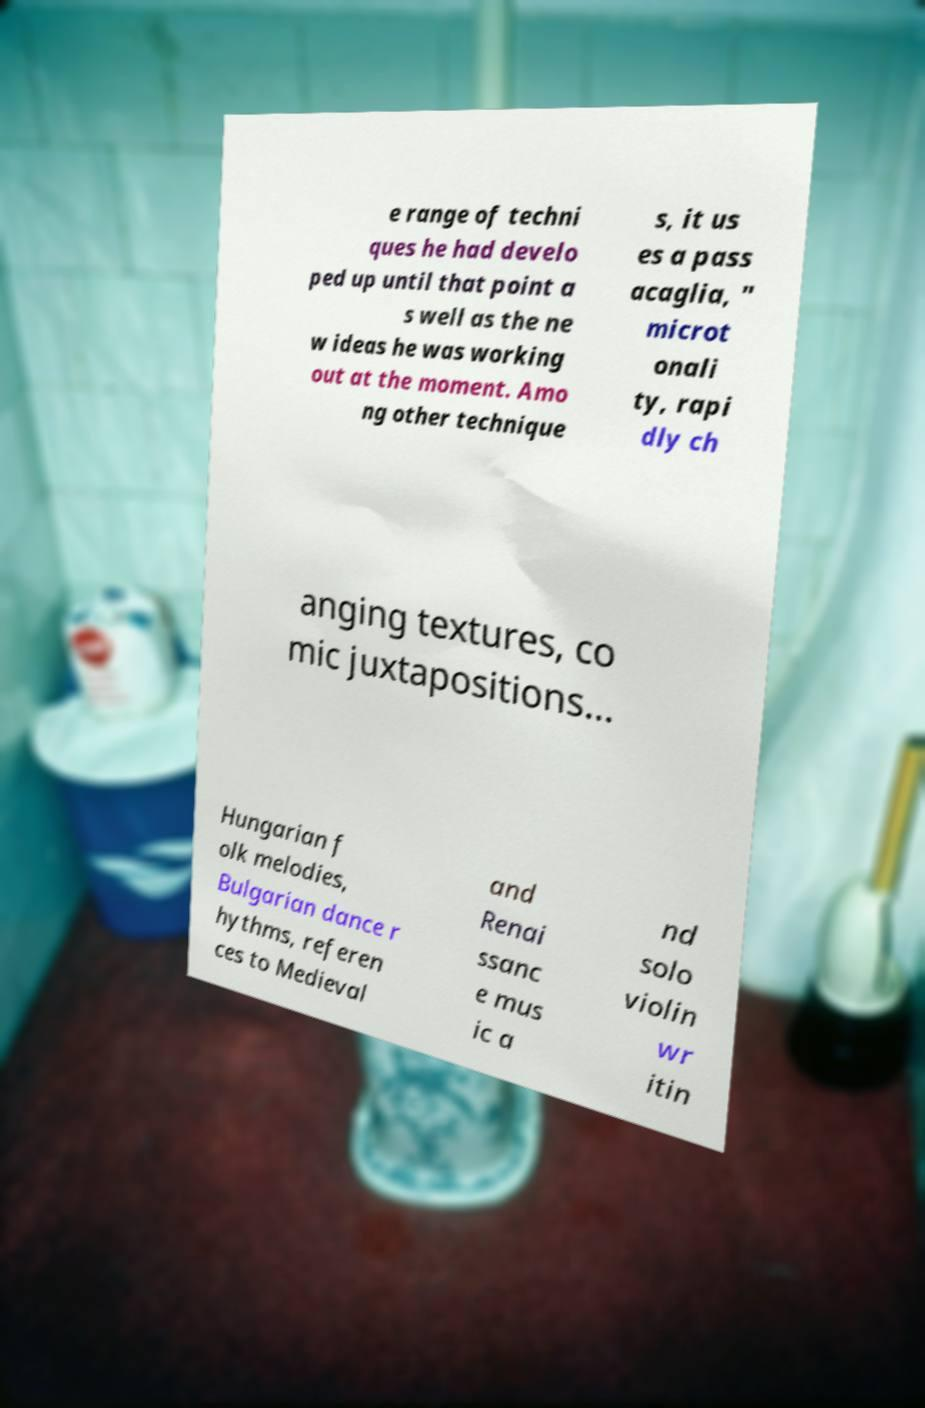Can you accurately transcribe the text from the provided image for me? e range of techni ques he had develo ped up until that point a s well as the ne w ideas he was working out at the moment. Amo ng other technique s, it us es a pass acaglia, " microt onali ty, rapi dly ch anging textures, co mic juxtapositions... Hungarian f olk melodies, Bulgarian dance r hythms, referen ces to Medieval and Renai ssanc e mus ic a nd solo violin wr itin 